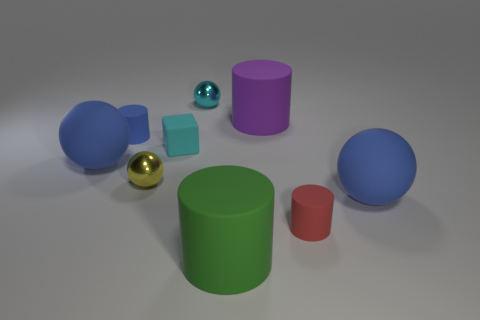Subtract all gray cylinders. How many blue spheres are left? 2 Subtract all small cyan balls. How many balls are left? 3 Subtract all cyan spheres. How many spheres are left? 3 Add 1 cylinders. How many objects exist? 10 Subtract all purple spheres. Subtract all green cubes. How many spheres are left? 4 Add 5 yellow things. How many yellow things are left? 6 Add 5 tiny cylinders. How many tiny cylinders exist? 7 Subtract 0 green cubes. How many objects are left? 9 Subtract all blocks. How many objects are left? 8 Subtract all large purple things. Subtract all big matte objects. How many objects are left? 4 